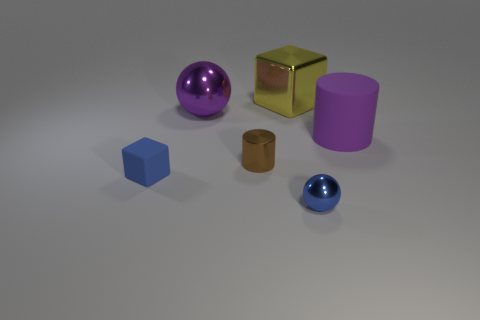Does the rubber thing that is in front of the brown object have the same color as the small metal sphere?
Offer a very short reply. Yes. Does the yellow metal object have the same size as the rubber block?
Your answer should be very brief. No. There is a purple thing that is the same size as the purple matte cylinder; what shape is it?
Give a very brief answer. Sphere. There is a cube right of the rubber cube; does it have the same size as the brown object?
Keep it short and to the point. No. What material is the yellow object that is the same size as the matte cylinder?
Give a very brief answer. Metal. There is a tiny thing that is to the right of the block behind the large purple rubber cylinder; is there a blue metal object in front of it?
Ensure brevity in your answer.  No. Is there anything else that is the same shape as the large purple metallic object?
Give a very brief answer. Yes. There is a sphere in front of the large purple rubber cylinder; does it have the same color as the large thing to the left of the big yellow shiny block?
Make the answer very short. No. Are any big brown rubber things visible?
Your response must be concise. No. There is a thing that is the same color as the small matte cube; what material is it?
Offer a terse response. Metal. 